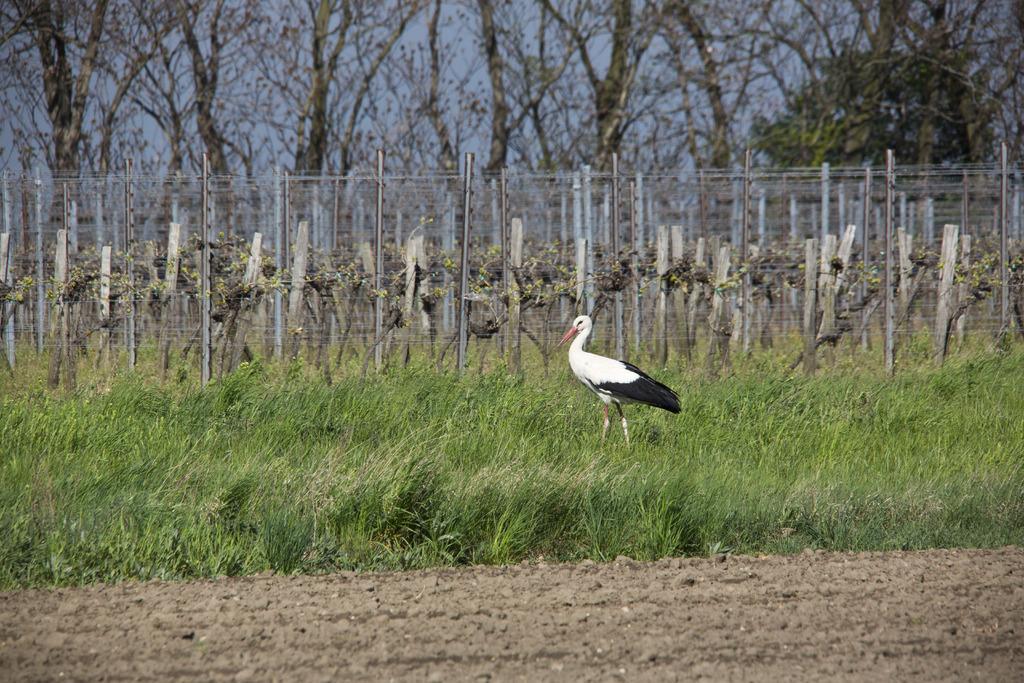How would you summarize this image in a sentence or two? This picture is clicked outside. In the center we can see a bird standing on the ground and we can see the green grass. In the background we can see the sky, trees, metal rods and some other objects. 